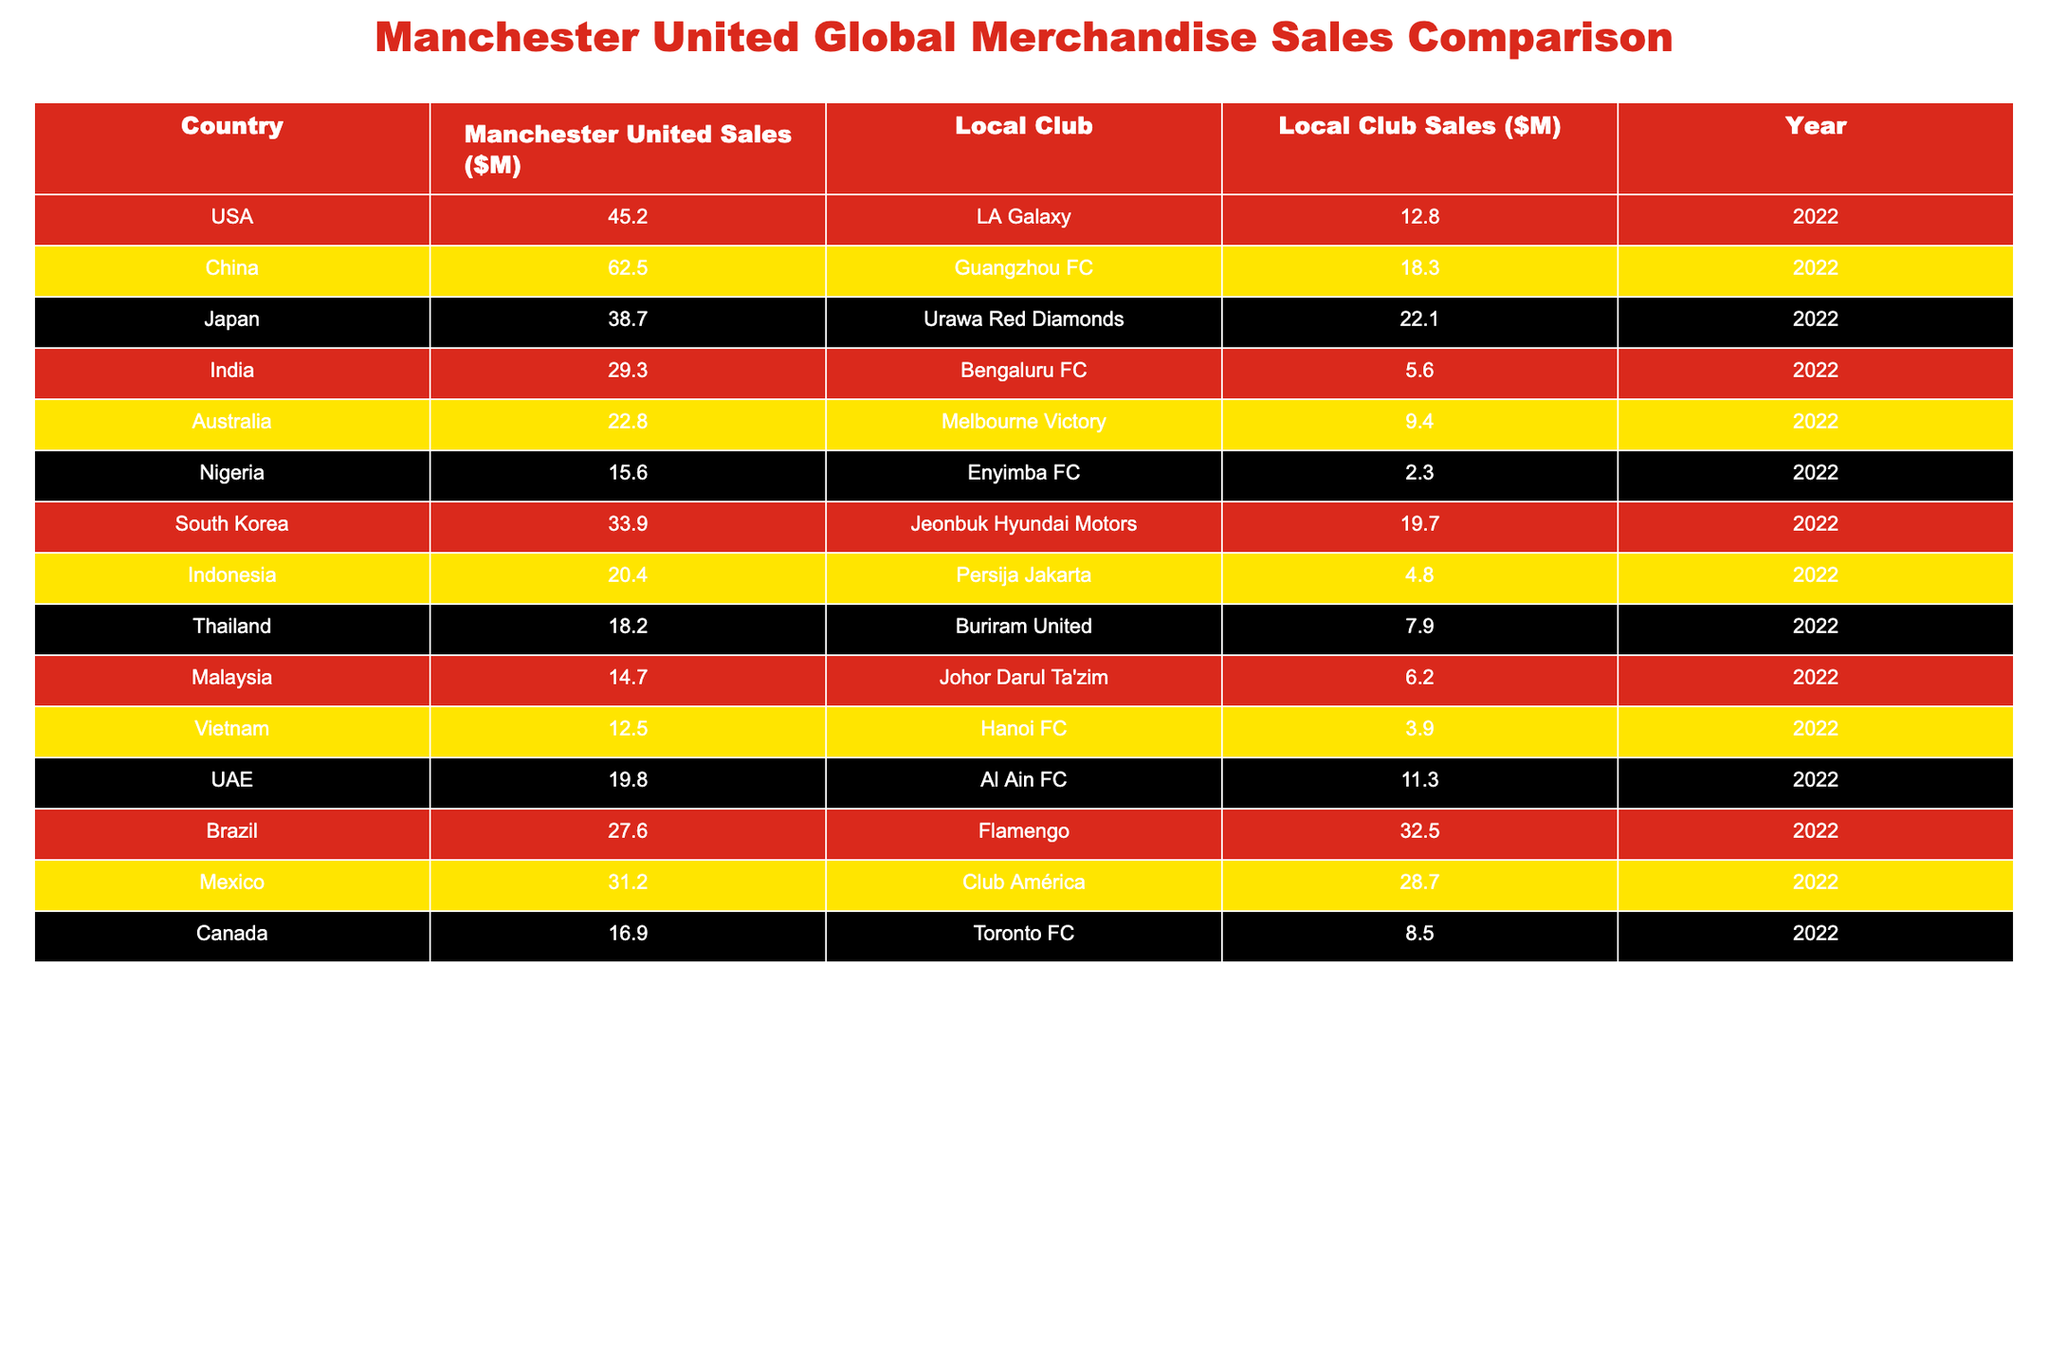What are the merchandise sales figures for Manchester United in India? The table shows that the merchandise sales figures for Manchester United in India are $29.3 million.
Answer: 29.3 million Which local club has the highest merchandise sales among the listed countries? By comparing the local club sales figures, Flamengo in Brazil has the highest at $32.5 million.
Answer: Flamengo with $32.5 million What is the total merchandise sales figure for Manchester United across all listed countries? Adding up the sales figures: 45.2 + 62.5 + 38.7 + 29.3 + 22.8 + 15.6 + 33.9 + 20.4 + 18.2 + 14.7 + 12.5 + 19.8 + 27.6 + 31.2 + 16.9 =  426.6 million.
Answer: 426.6 million Which country shows the largest gap in sales between Manchester United and its local club? Comparing the differences in sales: USA (45.2 - 12.8 = 32.4), China (62.5 - 18.3 = 44.2), Brazil (27.6 - 32.5 = -4.9), etc., yields the largest gap in China of $44.2 million.
Answer: China with a gap of $44.2 million Is it true that in Australia, Manchester United's sales exceed local club sales by more than $10 million? In Australia, Manchester United sales are $22.8 million and local club sales are $9.4 million, making the difference $13.4 million, which is indeed more than $10 million.
Answer: Yes What percentage of the total local club sales in the USA and Mexico comes from Manchester United? Local sales in the USA are $12.8 million and in Mexico are $28.7 million, totaling $41.5 million. Manchester United's sales are $45.2 million in the USA only. The percentage is (45.2 / 41.5) * 100 = 108.9%.
Answer: 108.9% How do Manchester United merchandise sales in Vietnam compare to those in Indonesia? In Vietnam, sales are $12.5 million while in Indonesia, sales are $20.4 million. Thus, sales in Indonesia are $7.9 million higher than in Vietnam.
Answer: Indonesia's sales are higher by $7.9 million What is the average merchandise sales figure for the local clubs listed? The local club sales figures are: 12.8, 18.3, 22.1, 5.6, 9.4, 2.3, 19.7, 4.8, 7.9, 6.2, 3.9, 11.3, 32.5, 28.7, 8.5, totaling  214.8 million across 15 clubs giving an average of 214.8 / 15 = 14.32 million.
Answer: 14.32 million Does the total merchandise sales figure for local clubs exceed that of Manchester United? The total local club sales are $214.8 million while Manchester United’s sales total $426.6 million; hence, local clubs do not exceed Manchester United.
Answer: No In which country does Manchester United have the least merchandise sales compared to its local club? In Nigeria, Manchester United's sales at $15.6 million are significantly higher than Enyimba FC's $2.3 million, indicating United has less relative advantage there.
Answer: Nigeria 